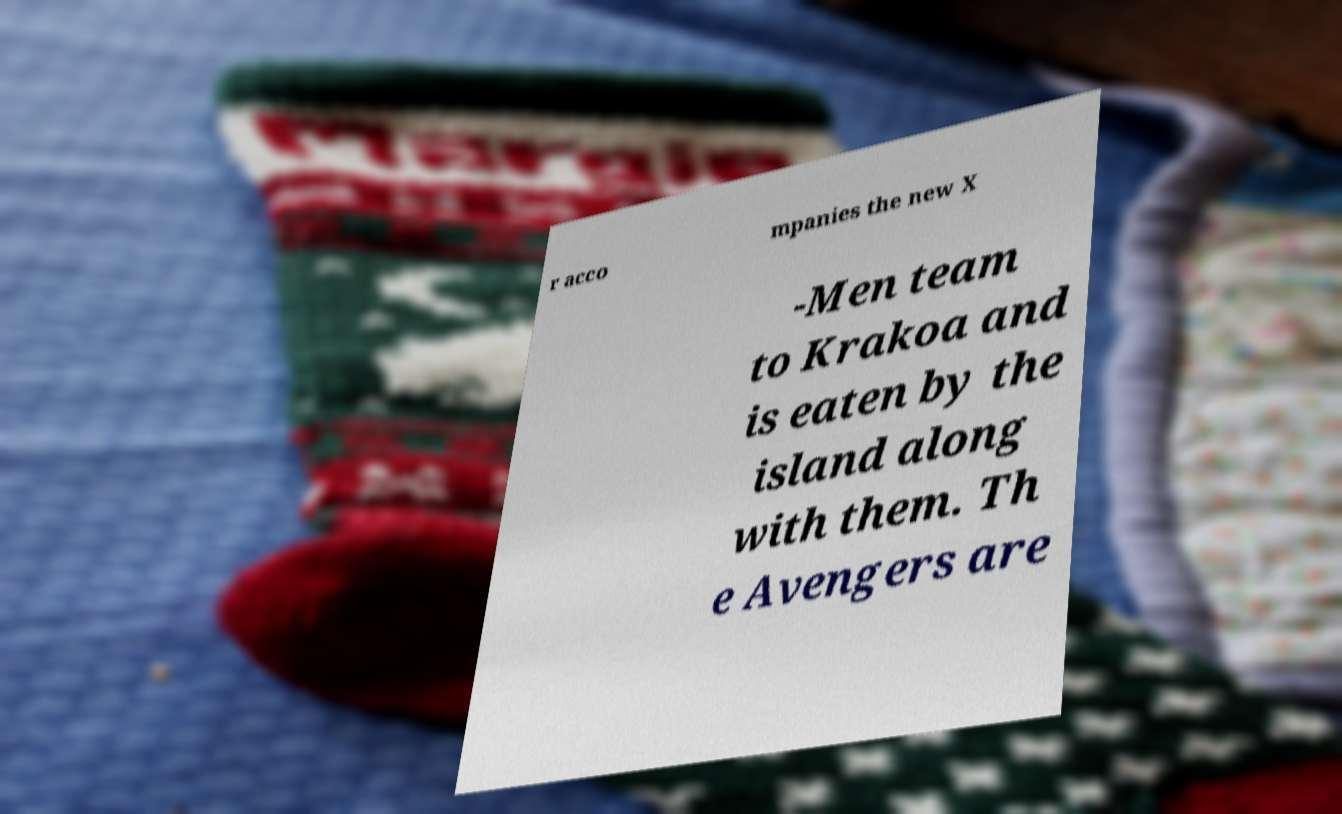There's text embedded in this image that I need extracted. Can you transcribe it verbatim? r acco mpanies the new X -Men team to Krakoa and is eaten by the island along with them. Th e Avengers are 